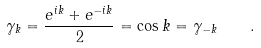<formula> <loc_0><loc_0><loc_500><loc_500>\gamma _ { k } = \frac { e ^ { i k } + e ^ { - i k } } { 2 } = \cos k = \gamma _ { - k } \quad .</formula> 